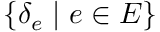<formula> <loc_0><loc_0><loc_500><loc_500>\{ \delta _ { e } | e \in E \}</formula> 